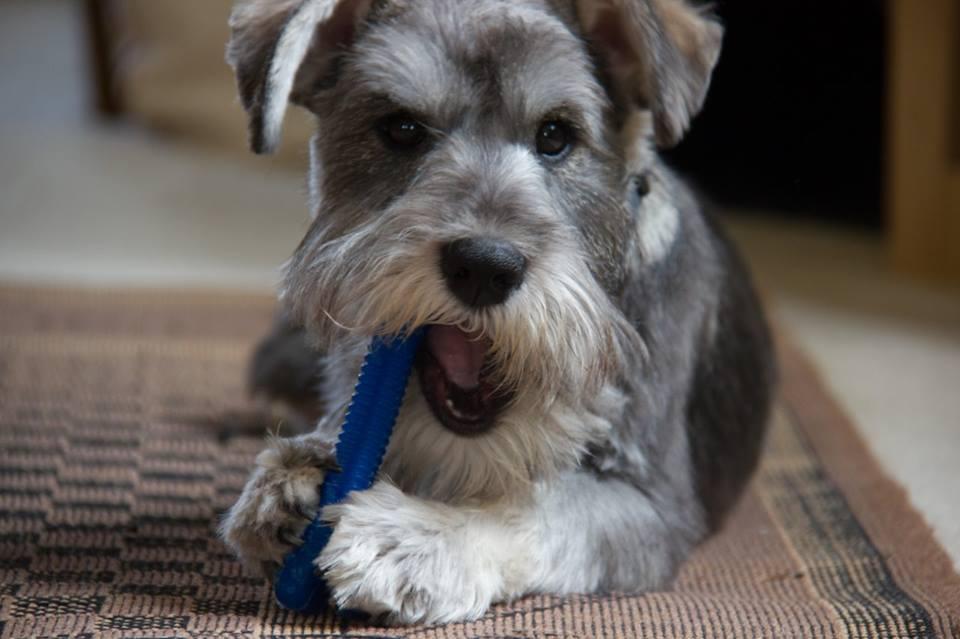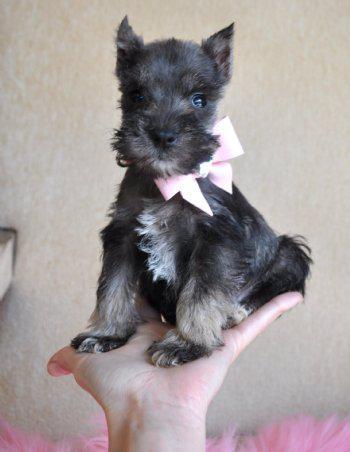The first image is the image on the left, the second image is the image on the right. Assess this claim about the two images: "The dog in the left photo is biting something.". Correct or not? Answer yes or no. Yes. The first image is the image on the left, the second image is the image on the right. Assess this claim about the two images: "In one image, a little dog with ears flopping forward has a blue toy at its front feet.". Correct or not? Answer yes or no. Yes. 